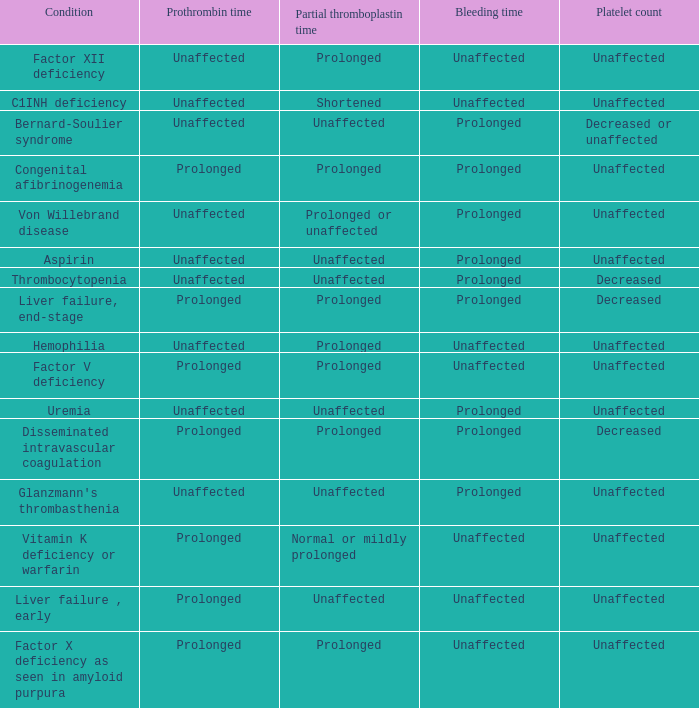Which Platelet count has a Condition of bernard-soulier syndrome? Decreased or unaffected. 